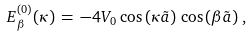<formula> <loc_0><loc_0><loc_500><loc_500>E ^ { ( 0 ) } _ { \beta } ( \kappa ) \, = \, - 4 V _ { 0 } \, \cos \left ( \kappa \tilde { a } \right ) \, \cos \left ( \beta \tilde { a } \right ) \, ,</formula> 